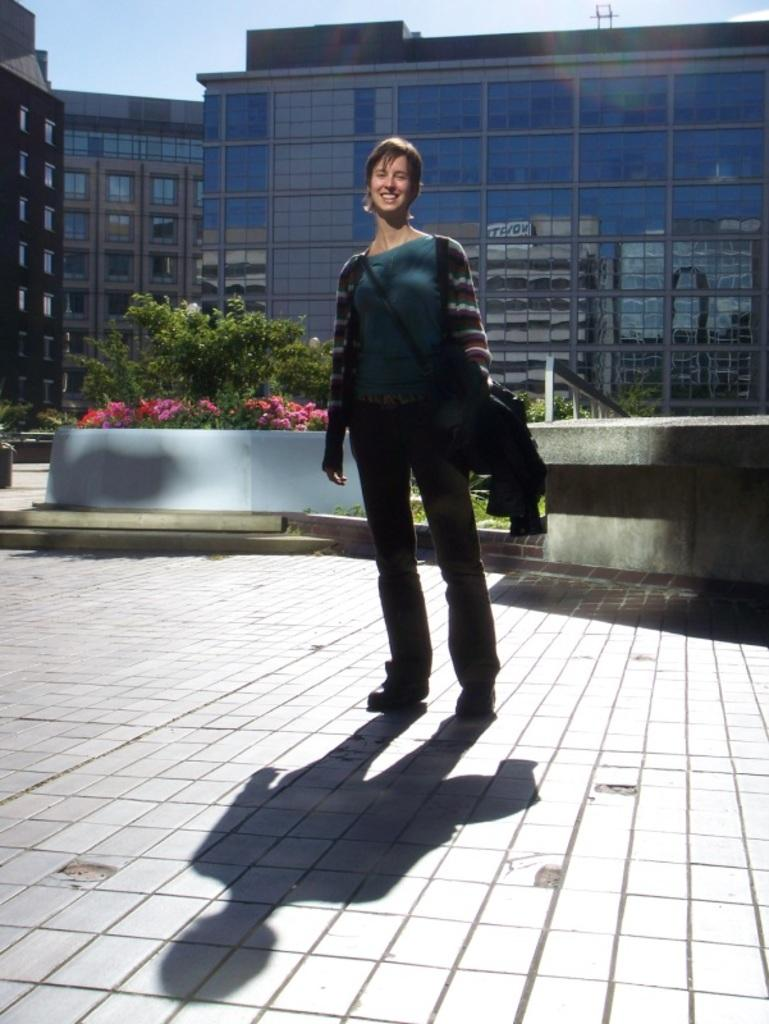What is the lady doing in the center of the image? The lady is standing and smiling in the center of the image. What can be seen in the background of the image? There are plants, flowers, buildings, and the sky visible in the background of the image. Does the lady need to seek approval from the plants in the image? There is no indication in the image that the lady needs to seek approval from the plants, as plants do not have the ability to grant or deny approval. 